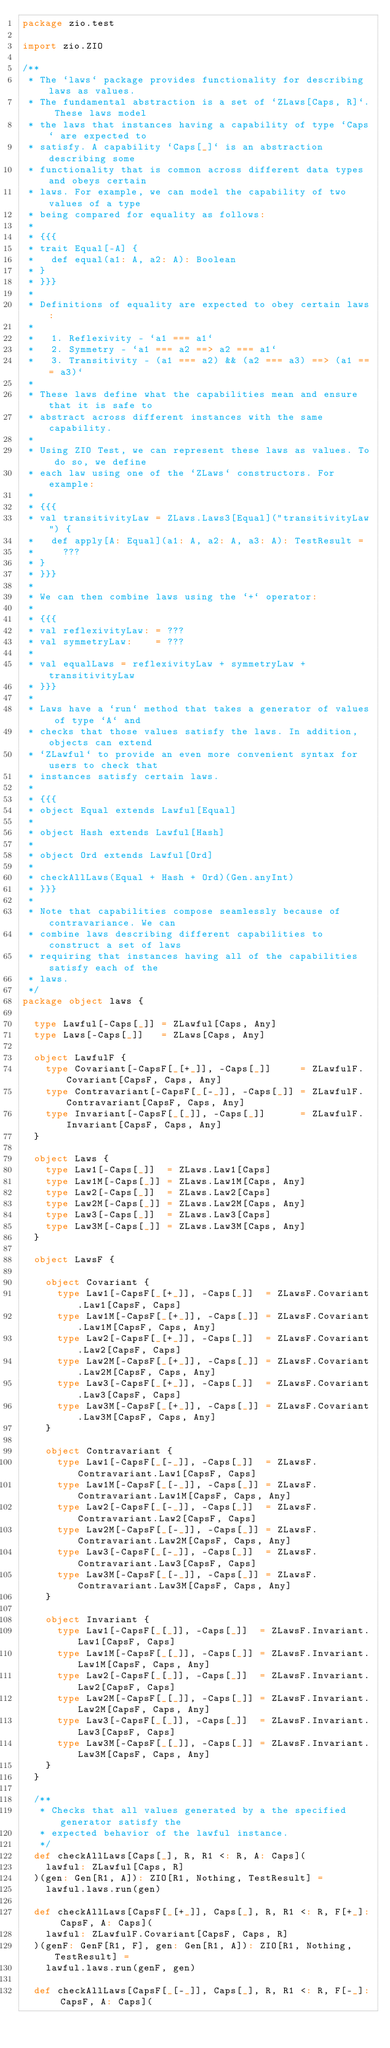Convert code to text. <code><loc_0><loc_0><loc_500><loc_500><_Scala_>package zio.test

import zio.ZIO

/**
 * The `laws` package provides functionality for describing laws as values.
 * The fundamental abstraction is a set of `ZLaws[Caps, R]`. These laws model
 * the laws that instances having a capability of type `Caps` are expected to
 * satisfy. A capability `Caps[_]` is an abstraction describing some
 * functionality that is common across different data types and obeys certain
 * laws. For example, we can model the capability of two values of a type
 * being compared for equality as follows:
 *
 * {{{
 * trait Equal[-A] {
 *   def equal(a1: A, a2: A): Boolean
 * }
 * }}}
 *
 * Definitions of equality are expected to obey certain laws:
 *
 *   1. Reflexivity - `a1 === a1`
 *   2. Symmetry - `a1 === a2 ==> a2 === a1`
 *   3. Transitivity - (a1 === a2) && (a2 === a3) ==> (a1 === a3)`
 *
 * These laws define what the capabilities mean and ensure that it is safe to
 * abstract across different instances with the same capability.
 *
 * Using ZIO Test, we can represent these laws as values. To do so, we define
 * each law using one of the `ZLaws` constructors. For example:
 *
 * {{{
 * val transitivityLaw = ZLaws.Laws3[Equal]("transitivityLaw") {
 *   def apply[A: Equal](a1: A, a2: A, a3: A): TestResult =
 *     ???
 * }
 * }}}
 *
 * We can then combine laws using the `+` operator:
 *
 * {{{
 * val reflexivityLaw: = ???
 * val symmetryLaw:    = ???
 *
 * val equalLaws = reflexivityLaw + symmetryLaw + transitivityLaw
 * }}}
 *
 * Laws have a `run` method that takes a generator of values of type `A` and
 * checks that those values satisfy the laws. In addition, objects can extend
 * `ZLawful` to provide an even more convenient syntax for users to check that
 * instances satisfy certain laws.
 *
 * {{{
 * object Equal extends Lawful[Equal]
 *
 * object Hash extends Lawful[Hash]
 *
 * object Ord extends Lawful[Ord]
 *
 * checkAllLaws(Equal + Hash + Ord)(Gen.anyInt)
 * }}}
 *
 * Note that capabilities compose seamlessly because of contravariance. We can
 * combine laws describing different capabilities to construct a set of laws
 * requiring that instances having all of the capabilities satisfy each of the
 * laws.
 */
package object laws {

  type Lawful[-Caps[_]] = ZLawful[Caps, Any]
  type Laws[-Caps[_]]   = ZLaws[Caps, Any]

  object LawfulF {
    type Covariant[-CapsF[_[+_]], -Caps[_]]     = ZLawfulF.Covariant[CapsF, Caps, Any]
    type Contravariant[-CapsF[_[-_]], -Caps[_]] = ZLawfulF.Contravariant[CapsF, Caps, Any]
    type Invariant[-CapsF[_[_]], -Caps[_]]      = ZLawfulF.Invariant[CapsF, Caps, Any]
  }

  object Laws {
    type Law1[-Caps[_]]  = ZLaws.Law1[Caps]
    type Law1M[-Caps[_]] = ZLaws.Law1M[Caps, Any]
    type Law2[-Caps[_]]  = ZLaws.Law2[Caps]
    type Law2M[-Caps[_]] = ZLaws.Law2M[Caps, Any]
    type Law3[-Caps[_]]  = ZLaws.Law3[Caps]
    type Law3M[-Caps[_]] = ZLaws.Law3M[Caps, Any]
  }

  object LawsF {

    object Covariant {
      type Law1[-CapsF[_[+_]], -Caps[_]]  = ZLawsF.Covariant.Law1[CapsF, Caps]
      type Law1M[-CapsF[_[+_]], -Caps[_]] = ZLawsF.Covariant.Law1M[CapsF, Caps, Any]
      type Law2[-CapsF[_[+_]], -Caps[_]]  = ZLawsF.Covariant.Law2[CapsF, Caps]
      type Law2M[-CapsF[_[+_]], -Caps[_]] = ZLawsF.Covariant.Law2M[CapsF, Caps, Any]
      type Law3[-CapsF[_[+_]], -Caps[_]]  = ZLawsF.Covariant.Law3[CapsF, Caps]
      type Law3M[-CapsF[_[+_]], -Caps[_]] = ZLawsF.Covariant.Law3M[CapsF, Caps, Any]
    }

    object Contravariant {
      type Law1[-CapsF[_[-_]], -Caps[_]]  = ZLawsF.Contravariant.Law1[CapsF, Caps]
      type Law1M[-CapsF[_[-_]], -Caps[_]] = ZLawsF.Contravariant.Law1M[CapsF, Caps, Any]
      type Law2[-CapsF[_[-_]], -Caps[_]]  = ZLawsF.Contravariant.Law2[CapsF, Caps]
      type Law2M[-CapsF[_[-_]], -Caps[_]] = ZLawsF.Contravariant.Law2M[CapsF, Caps, Any]
      type Law3[-CapsF[_[-_]], -Caps[_]]  = ZLawsF.Contravariant.Law3[CapsF, Caps]
      type Law3M[-CapsF[_[-_]], -Caps[_]] = ZLawsF.Contravariant.Law3M[CapsF, Caps, Any]
    }

    object Invariant {
      type Law1[-CapsF[_[_]], -Caps[_]]  = ZLawsF.Invariant.Law1[CapsF, Caps]
      type Law1M[-CapsF[_[_]], -Caps[_]] = ZLawsF.Invariant.Law1M[CapsF, Caps, Any]
      type Law2[-CapsF[_[_]], -Caps[_]]  = ZLawsF.Invariant.Law2[CapsF, Caps]
      type Law2M[-CapsF[_[_]], -Caps[_]] = ZLawsF.Invariant.Law2M[CapsF, Caps, Any]
      type Law3[-CapsF[_[_]], -Caps[_]]  = ZLawsF.Invariant.Law3[CapsF, Caps]
      type Law3M[-CapsF[_[_]], -Caps[_]] = ZLawsF.Invariant.Law3M[CapsF, Caps, Any]
    }
  }

  /**
   * Checks that all values generated by a the specified generator satisfy the
   * expected behavior of the lawful instance.
   */
  def checkAllLaws[Caps[_], R, R1 <: R, A: Caps](
    lawful: ZLawful[Caps, R]
  )(gen: Gen[R1, A]): ZIO[R1, Nothing, TestResult] =
    lawful.laws.run(gen)

  def checkAllLaws[CapsF[_[+_]], Caps[_], R, R1 <: R, F[+_]: CapsF, A: Caps](
    lawful: ZLawfulF.Covariant[CapsF, Caps, R]
  )(genF: GenF[R1, F], gen: Gen[R1, A]): ZIO[R1, Nothing, TestResult] =
    lawful.laws.run(genF, gen)

  def checkAllLaws[CapsF[_[-_]], Caps[_], R, R1 <: R, F[-_]: CapsF, A: Caps](</code> 